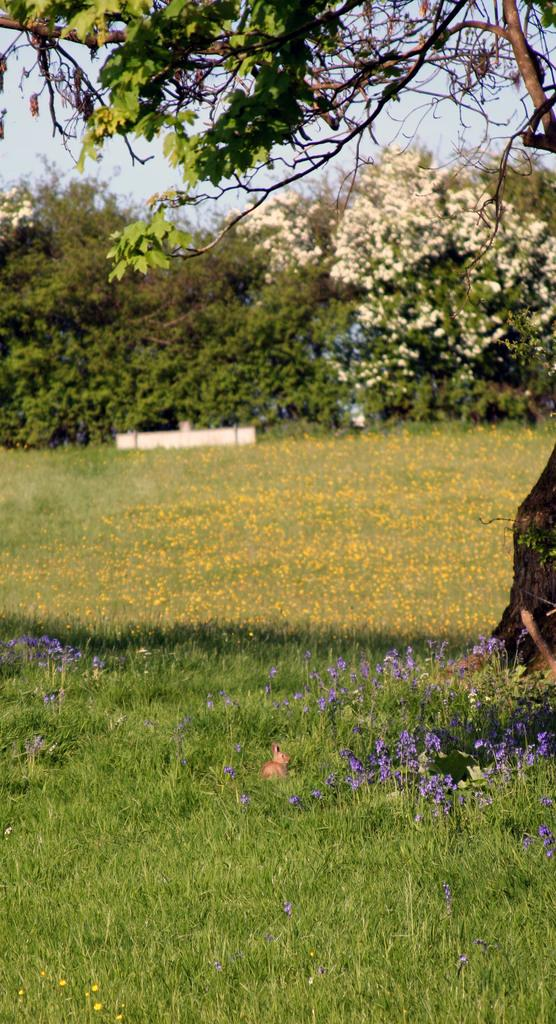What type of plants are in the image? There are flowers in the image. What color are the flowers? The flowers are white. What can be seen in the background of the image? There are trees, grass, and the sky visible in the background of the image. What color are the trees and grass? The trees and grass are green. What color is the sky in the image? The sky is blue. What is the price of the zoo in the image? There is no zoo present in the image, so it is not possible to determine its price. 